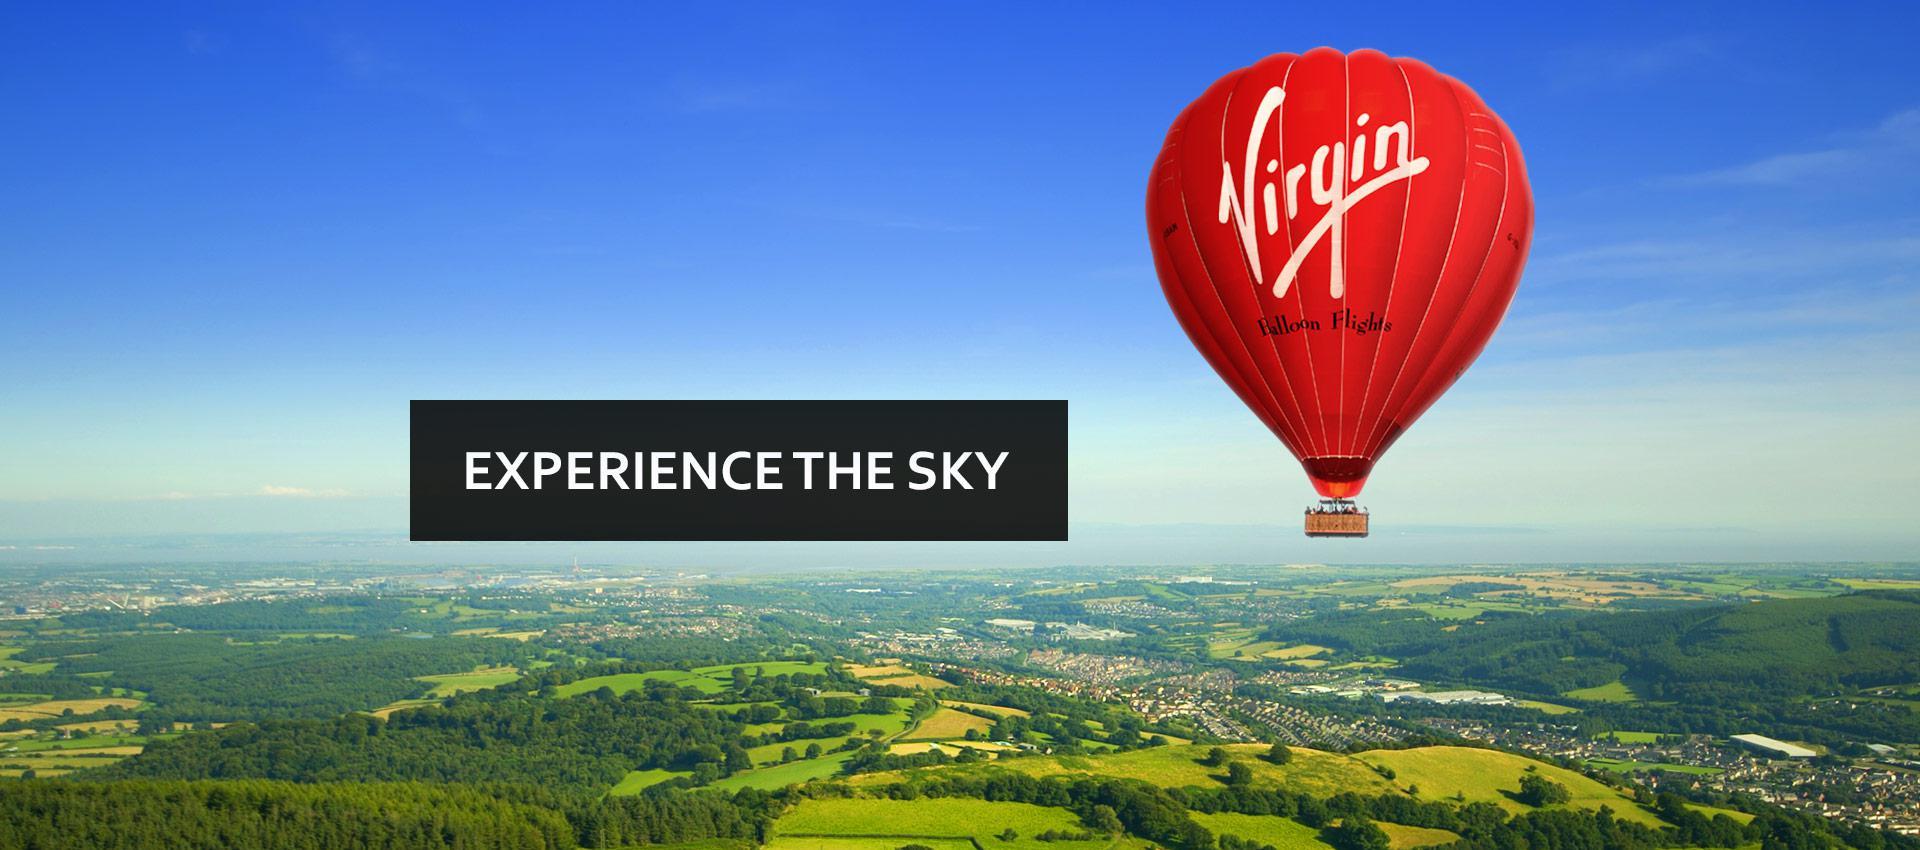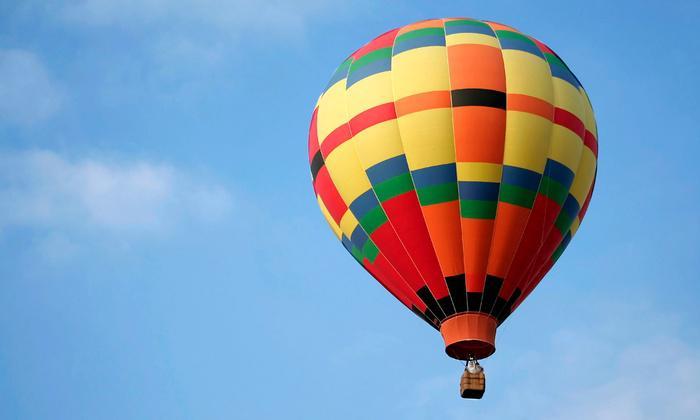The first image is the image on the left, the second image is the image on the right. For the images displayed, is the sentence "In one image, a face is designed on the side of a large yellow hot-air balloon." factually correct? Answer yes or no. No. The first image is the image on the left, the second image is the image on the right. Analyze the images presented: Is the assertion "In one image, the balloon in the foreground has a face." valid? Answer yes or no. No. 